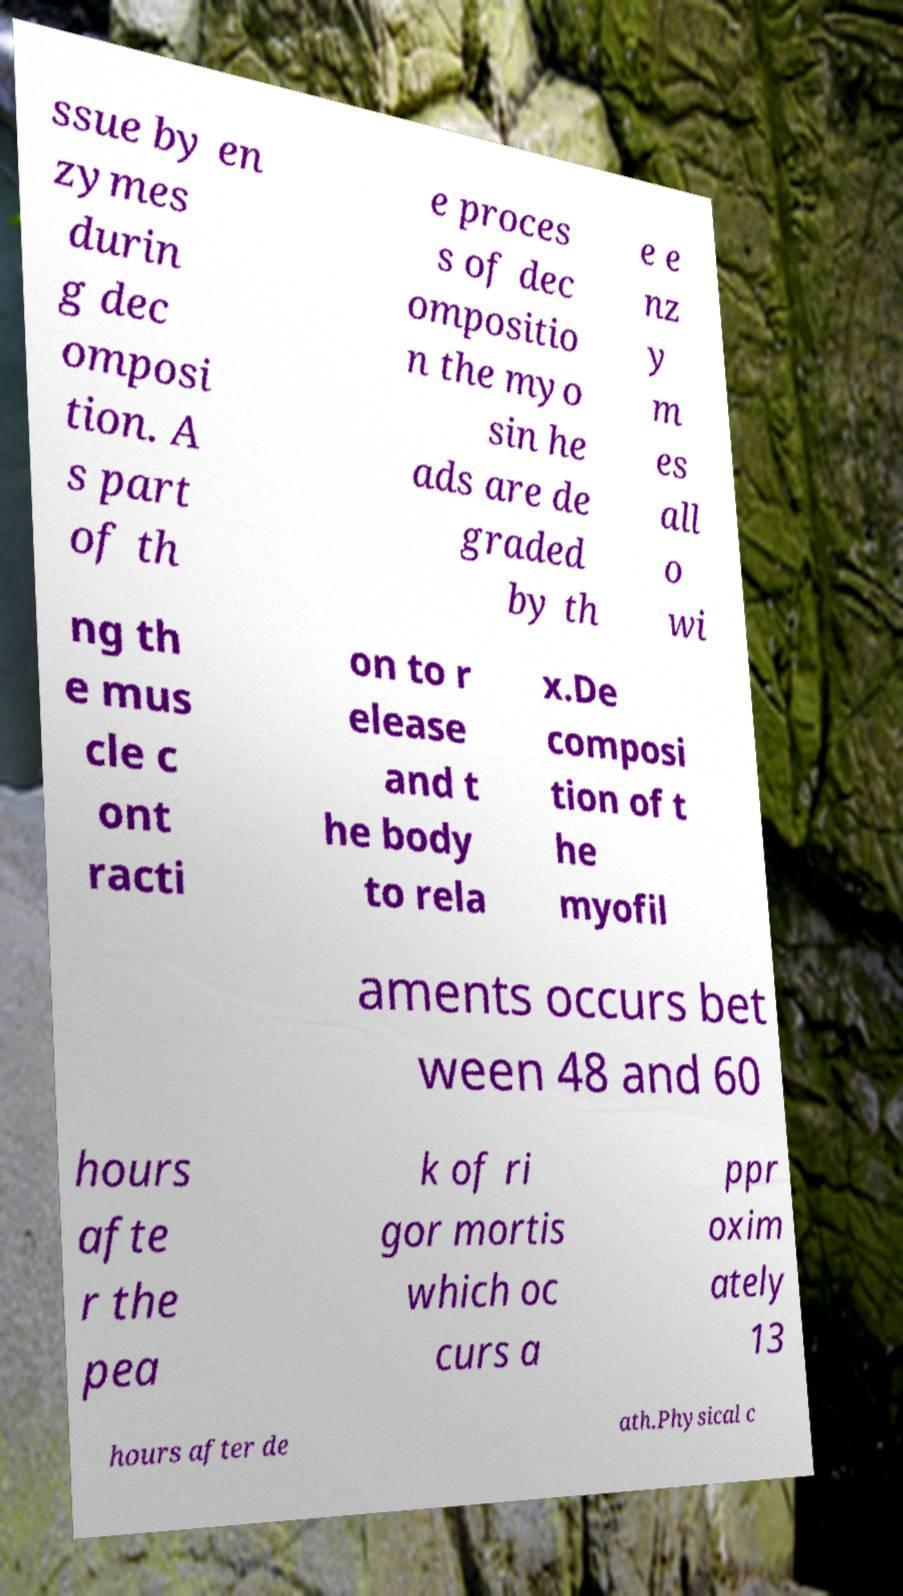There's text embedded in this image that I need extracted. Can you transcribe it verbatim? ssue by en zymes durin g dec omposi tion. A s part of th e proces s of dec ompositio n the myo sin he ads are de graded by th e e nz y m es all o wi ng th e mus cle c ont racti on to r elease and t he body to rela x.De composi tion of t he myofil aments occurs bet ween 48 and 60 hours afte r the pea k of ri gor mortis which oc curs a ppr oxim ately 13 hours after de ath.Physical c 